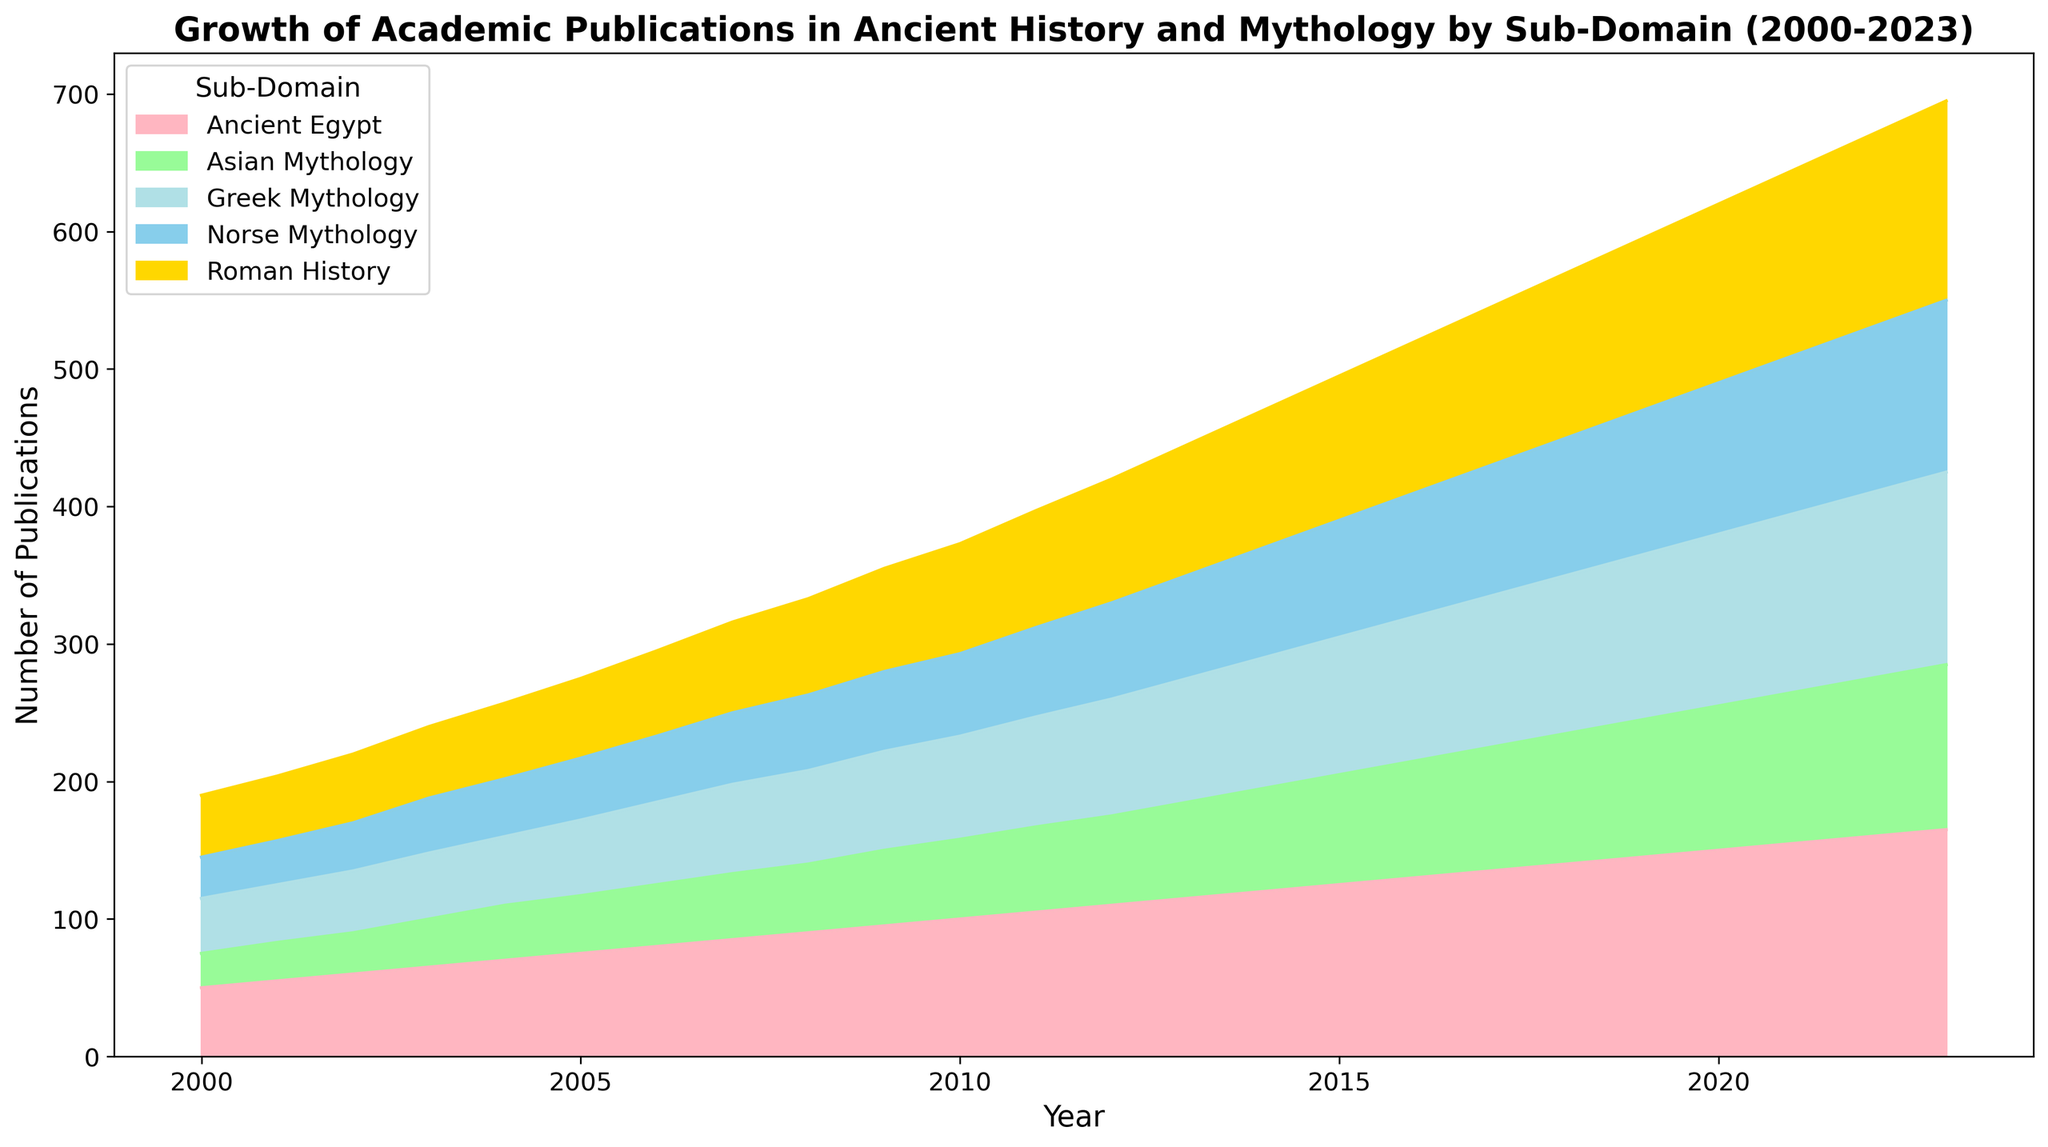What was the total number of academic publications in 2023 across all sub-domains? To find the total number of publications in 2023, sum the publications from each sub-domain: Ancient Egypt (165) + Greek Mythology (140) + Roman History (145) + Norse Mythology (125) + Asian Mythology (120). This gives 165 + 140 + 145 + 125 + 120 = 695.
Answer: 695 What is the average number of publications in Asian Mythology from 2000 to 2023? First, sum the publications for Asian Mythology from 2000 to 2023. The sum is 25 + 28 + 30 + 35 + 40 + 42 + 45 + 48 + 50 + 55 + 58 + 62 + 65 + 70 + 75 + 80 + 85 + 90 + 95 + 100 + 105 + 110 + 115 + 120 = 1640. Then, divide this sum by the number of years, which is 24. So, 1640 / 24 ≈ 68.33.
Answer: 68.33 Between which years did Ancient Egypt see an increase from below 100 to above 150 publications? From the data for Ancient Egypt: 
In 2010, it had 100 publications, and in 2020, it had 150 publications. The years between 2010 and 2020 are where the increase occurs.
Answer: 2010-2020 Which sub-domain consistently remained the lowest in terms of publications each year from 2000 to 2023? By examining the data, Asian Mythology starts at the lowest in 2000 and remains at the lowest consistently in each subsequent year up to 2023.
Answer: Asian Mythology Compare the number of publications in Greek Mythology and Norse Mythology in 2010. Which one had more? In 2010, Greek Mythology had 75 publications while Norse Mythology had 60 publications. Therefore, Greek Mythology had more.
Answer: Greek Mythology What was the combined number of publications for Greek Mythology and Roman History in 2010? To find the combined number, add the publications for Greek Mythology (75) and Roman History (80) in 2010. This gives 75 + 80 = 155.
Answer: 155 